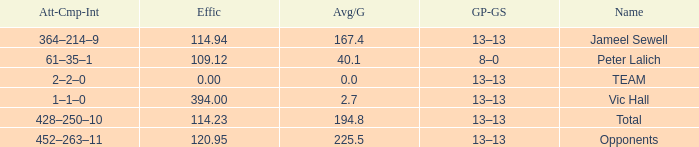Avg/G of 2.7 is what effic? 394.0. 